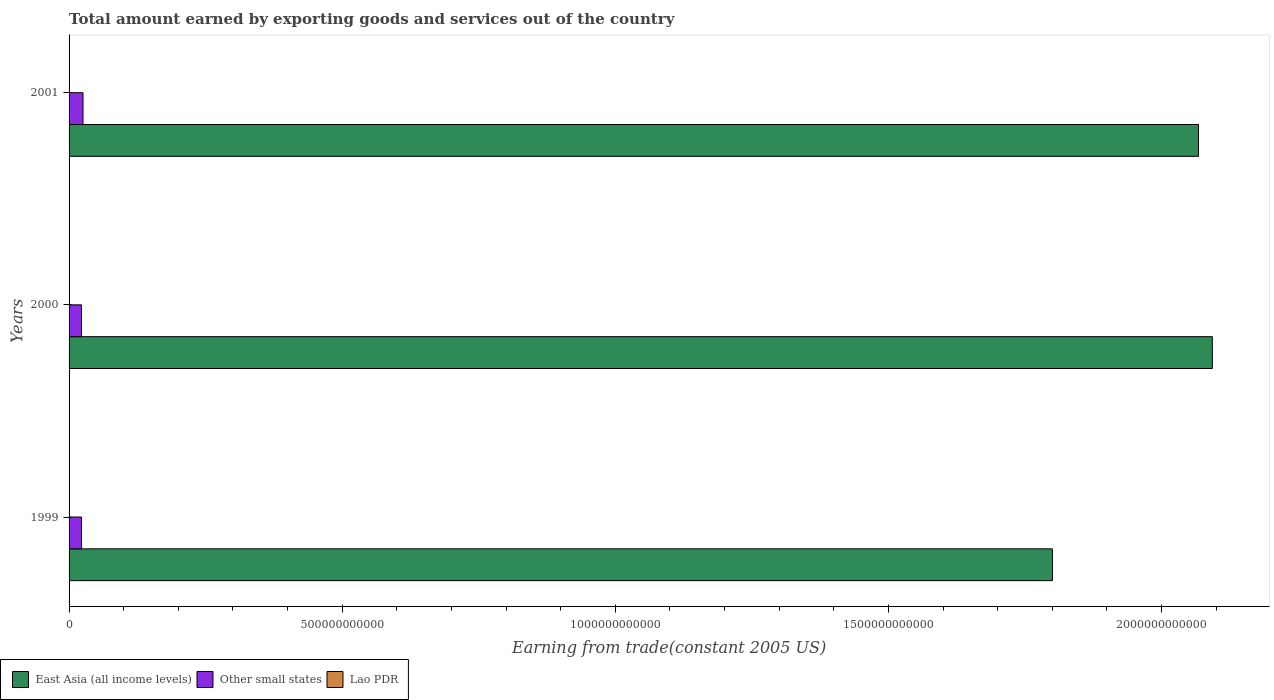How many different coloured bars are there?
Your answer should be compact. 3. How many groups of bars are there?
Ensure brevity in your answer.  3. Are the number of bars per tick equal to the number of legend labels?
Give a very brief answer. Yes. Are the number of bars on each tick of the Y-axis equal?
Give a very brief answer. Yes. How many bars are there on the 3rd tick from the top?
Your answer should be very brief. 3. How many bars are there on the 2nd tick from the bottom?
Keep it short and to the point. 3. What is the label of the 3rd group of bars from the top?
Offer a terse response. 1999. What is the total amount earned by exporting goods and services in East Asia (all income levels) in 2001?
Your response must be concise. 2.07e+12. Across all years, what is the maximum total amount earned by exporting goods and services in Other small states?
Your answer should be very brief. 2.55e+1. Across all years, what is the minimum total amount earned by exporting goods and services in Lao PDR?
Give a very brief answer. 6.32e+08. What is the total total amount earned by exporting goods and services in Lao PDR in the graph?
Give a very brief answer. 1.96e+09. What is the difference between the total amount earned by exporting goods and services in Other small states in 2000 and that in 2001?
Keep it short and to the point. -2.80e+09. What is the difference between the total amount earned by exporting goods and services in Other small states in 2000 and the total amount earned by exporting goods and services in East Asia (all income levels) in 2001?
Keep it short and to the point. -2.04e+12. What is the average total amount earned by exporting goods and services in Other small states per year?
Provide a short and direct response. 2.37e+1. In the year 1999, what is the difference between the total amount earned by exporting goods and services in Lao PDR and total amount earned by exporting goods and services in Other small states?
Your answer should be compact. -2.21e+1. What is the ratio of the total amount earned by exporting goods and services in East Asia (all income levels) in 1999 to that in 2001?
Ensure brevity in your answer.  0.87. Is the difference between the total amount earned by exporting goods and services in Lao PDR in 2000 and 2001 greater than the difference between the total amount earned by exporting goods and services in Other small states in 2000 and 2001?
Your answer should be compact. Yes. What is the difference between the highest and the second highest total amount earned by exporting goods and services in East Asia (all income levels)?
Provide a short and direct response. 2.53e+1. What is the difference between the highest and the lowest total amount earned by exporting goods and services in Other small states?
Make the answer very short. 2.80e+09. What does the 1st bar from the top in 2000 represents?
Keep it short and to the point. Lao PDR. What does the 1st bar from the bottom in 2000 represents?
Your response must be concise. East Asia (all income levels). What is the difference between two consecutive major ticks on the X-axis?
Offer a very short reply. 5.00e+11. Where does the legend appear in the graph?
Offer a very short reply. Bottom left. How many legend labels are there?
Your answer should be compact. 3. How are the legend labels stacked?
Your answer should be very brief. Horizontal. What is the title of the graph?
Make the answer very short. Total amount earned by exporting goods and services out of the country. What is the label or title of the X-axis?
Offer a very short reply. Earning from trade(constant 2005 US). What is the label or title of the Y-axis?
Your answer should be very brief. Years. What is the Earning from trade(constant 2005 US) of East Asia (all income levels) in 1999?
Your answer should be compact. 1.80e+12. What is the Earning from trade(constant 2005 US) of Other small states in 1999?
Your response must be concise. 2.28e+1. What is the Earning from trade(constant 2005 US) of Lao PDR in 1999?
Your answer should be very brief. 6.95e+08. What is the Earning from trade(constant 2005 US) in East Asia (all income levels) in 2000?
Provide a succinct answer. 2.09e+12. What is the Earning from trade(constant 2005 US) of Other small states in 2000?
Your response must be concise. 2.27e+1. What is the Earning from trade(constant 2005 US) in Lao PDR in 2000?
Provide a succinct answer. 6.32e+08. What is the Earning from trade(constant 2005 US) of East Asia (all income levels) in 2001?
Your answer should be very brief. 2.07e+12. What is the Earning from trade(constant 2005 US) of Other small states in 2001?
Your answer should be very brief. 2.55e+1. What is the Earning from trade(constant 2005 US) in Lao PDR in 2001?
Offer a very short reply. 6.34e+08. Across all years, what is the maximum Earning from trade(constant 2005 US) in East Asia (all income levels)?
Give a very brief answer. 2.09e+12. Across all years, what is the maximum Earning from trade(constant 2005 US) in Other small states?
Your answer should be compact. 2.55e+1. Across all years, what is the maximum Earning from trade(constant 2005 US) in Lao PDR?
Provide a short and direct response. 6.95e+08. Across all years, what is the minimum Earning from trade(constant 2005 US) in East Asia (all income levels)?
Your answer should be very brief. 1.80e+12. Across all years, what is the minimum Earning from trade(constant 2005 US) of Other small states?
Ensure brevity in your answer.  2.27e+1. Across all years, what is the minimum Earning from trade(constant 2005 US) in Lao PDR?
Your answer should be very brief. 6.32e+08. What is the total Earning from trade(constant 2005 US) of East Asia (all income levels) in the graph?
Offer a terse response. 5.96e+12. What is the total Earning from trade(constant 2005 US) of Other small states in the graph?
Give a very brief answer. 7.10e+1. What is the total Earning from trade(constant 2005 US) of Lao PDR in the graph?
Give a very brief answer. 1.96e+09. What is the difference between the Earning from trade(constant 2005 US) of East Asia (all income levels) in 1999 and that in 2000?
Your response must be concise. -2.93e+11. What is the difference between the Earning from trade(constant 2005 US) in Other small states in 1999 and that in 2000?
Make the answer very short. 1.05e+08. What is the difference between the Earning from trade(constant 2005 US) of Lao PDR in 1999 and that in 2000?
Make the answer very short. 6.36e+07. What is the difference between the Earning from trade(constant 2005 US) in East Asia (all income levels) in 1999 and that in 2001?
Provide a short and direct response. -2.67e+11. What is the difference between the Earning from trade(constant 2005 US) in Other small states in 1999 and that in 2001?
Offer a terse response. -2.70e+09. What is the difference between the Earning from trade(constant 2005 US) of Lao PDR in 1999 and that in 2001?
Give a very brief answer. 6.15e+07. What is the difference between the Earning from trade(constant 2005 US) in East Asia (all income levels) in 2000 and that in 2001?
Keep it short and to the point. 2.53e+1. What is the difference between the Earning from trade(constant 2005 US) of Other small states in 2000 and that in 2001?
Give a very brief answer. -2.80e+09. What is the difference between the Earning from trade(constant 2005 US) in Lao PDR in 2000 and that in 2001?
Keep it short and to the point. -2.19e+06. What is the difference between the Earning from trade(constant 2005 US) of East Asia (all income levels) in 1999 and the Earning from trade(constant 2005 US) of Other small states in 2000?
Provide a succinct answer. 1.78e+12. What is the difference between the Earning from trade(constant 2005 US) of East Asia (all income levels) in 1999 and the Earning from trade(constant 2005 US) of Lao PDR in 2000?
Your answer should be compact. 1.80e+12. What is the difference between the Earning from trade(constant 2005 US) of Other small states in 1999 and the Earning from trade(constant 2005 US) of Lao PDR in 2000?
Provide a short and direct response. 2.22e+1. What is the difference between the Earning from trade(constant 2005 US) of East Asia (all income levels) in 1999 and the Earning from trade(constant 2005 US) of Other small states in 2001?
Provide a short and direct response. 1.77e+12. What is the difference between the Earning from trade(constant 2005 US) of East Asia (all income levels) in 1999 and the Earning from trade(constant 2005 US) of Lao PDR in 2001?
Offer a terse response. 1.80e+12. What is the difference between the Earning from trade(constant 2005 US) of Other small states in 1999 and the Earning from trade(constant 2005 US) of Lao PDR in 2001?
Your response must be concise. 2.22e+1. What is the difference between the Earning from trade(constant 2005 US) of East Asia (all income levels) in 2000 and the Earning from trade(constant 2005 US) of Other small states in 2001?
Provide a succinct answer. 2.07e+12. What is the difference between the Earning from trade(constant 2005 US) in East Asia (all income levels) in 2000 and the Earning from trade(constant 2005 US) in Lao PDR in 2001?
Provide a short and direct response. 2.09e+12. What is the difference between the Earning from trade(constant 2005 US) in Other small states in 2000 and the Earning from trade(constant 2005 US) in Lao PDR in 2001?
Make the answer very short. 2.21e+1. What is the average Earning from trade(constant 2005 US) in East Asia (all income levels) per year?
Ensure brevity in your answer.  1.99e+12. What is the average Earning from trade(constant 2005 US) in Other small states per year?
Ensure brevity in your answer.  2.37e+1. What is the average Earning from trade(constant 2005 US) of Lao PDR per year?
Ensure brevity in your answer.  6.53e+08. In the year 1999, what is the difference between the Earning from trade(constant 2005 US) of East Asia (all income levels) and Earning from trade(constant 2005 US) of Other small states?
Your answer should be compact. 1.78e+12. In the year 1999, what is the difference between the Earning from trade(constant 2005 US) of East Asia (all income levels) and Earning from trade(constant 2005 US) of Lao PDR?
Ensure brevity in your answer.  1.80e+12. In the year 1999, what is the difference between the Earning from trade(constant 2005 US) in Other small states and Earning from trade(constant 2005 US) in Lao PDR?
Give a very brief answer. 2.21e+1. In the year 2000, what is the difference between the Earning from trade(constant 2005 US) of East Asia (all income levels) and Earning from trade(constant 2005 US) of Other small states?
Give a very brief answer. 2.07e+12. In the year 2000, what is the difference between the Earning from trade(constant 2005 US) in East Asia (all income levels) and Earning from trade(constant 2005 US) in Lao PDR?
Offer a very short reply. 2.09e+12. In the year 2000, what is the difference between the Earning from trade(constant 2005 US) in Other small states and Earning from trade(constant 2005 US) in Lao PDR?
Ensure brevity in your answer.  2.21e+1. In the year 2001, what is the difference between the Earning from trade(constant 2005 US) of East Asia (all income levels) and Earning from trade(constant 2005 US) of Other small states?
Ensure brevity in your answer.  2.04e+12. In the year 2001, what is the difference between the Earning from trade(constant 2005 US) of East Asia (all income levels) and Earning from trade(constant 2005 US) of Lao PDR?
Offer a very short reply. 2.07e+12. In the year 2001, what is the difference between the Earning from trade(constant 2005 US) of Other small states and Earning from trade(constant 2005 US) of Lao PDR?
Make the answer very short. 2.49e+1. What is the ratio of the Earning from trade(constant 2005 US) in East Asia (all income levels) in 1999 to that in 2000?
Your answer should be very brief. 0.86. What is the ratio of the Earning from trade(constant 2005 US) of Lao PDR in 1999 to that in 2000?
Provide a succinct answer. 1.1. What is the ratio of the Earning from trade(constant 2005 US) of East Asia (all income levels) in 1999 to that in 2001?
Your answer should be compact. 0.87. What is the ratio of the Earning from trade(constant 2005 US) in Other small states in 1999 to that in 2001?
Offer a very short reply. 0.89. What is the ratio of the Earning from trade(constant 2005 US) in Lao PDR in 1999 to that in 2001?
Your answer should be compact. 1.1. What is the ratio of the Earning from trade(constant 2005 US) of East Asia (all income levels) in 2000 to that in 2001?
Your response must be concise. 1.01. What is the ratio of the Earning from trade(constant 2005 US) of Other small states in 2000 to that in 2001?
Make the answer very short. 0.89. What is the ratio of the Earning from trade(constant 2005 US) of Lao PDR in 2000 to that in 2001?
Offer a terse response. 1. What is the difference between the highest and the second highest Earning from trade(constant 2005 US) in East Asia (all income levels)?
Your response must be concise. 2.53e+1. What is the difference between the highest and the second highest Earning from trade(constant 2005 US) of Other small states?
Provide a succinct answer. 2.70e+09. What is the difference between the highest and the second highest Earning from trade(constant 2005 US) of Lao PDR?
Ensure brevity in your answer.  6.15e+07. What is the difference between the highest and the lowest Earning from trade(constant 2005 US) in East Asia (all income levels)?
Ensure brevity in your answer.  2.93e+11. What is the difference between the highest and the lowest Earning from trade(constant 2005 US) of Other small states?
Your response must be concise. 2.80e+09. What is the difference between the highest and the lowest Earning from trade(constant 2005 US) in Lao PDR?
Keep it short and to the point. 6.36e+07. 